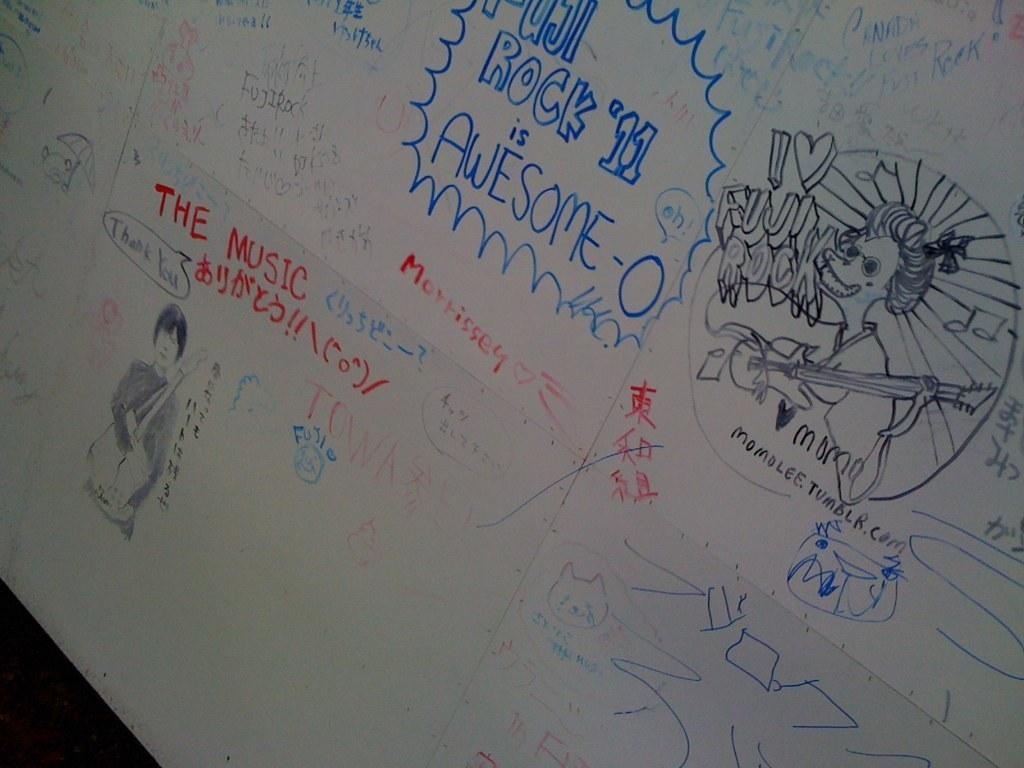<image>
Relay a brief, clear account of the picture shown. Whiteboard with a collection of drawings and words based on rock music. 